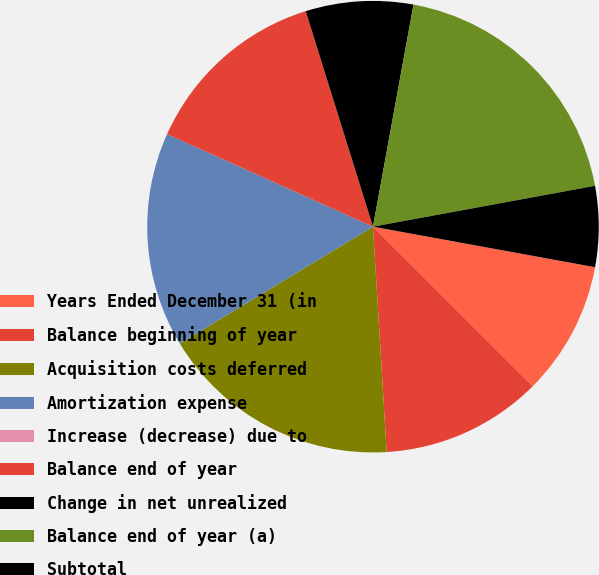<chart> <loc_0><loc_0><loc_500><loc_500><pie_chart><fcel>Years Ended December 31 (in<fcel>Balance beginning of year<fcel>Acquisition costs deferred<fcel>Amortization expense<fcel>Increase (decrease) due to<fcel>Balance end of year<fcel>Change in net unrealized<fcel>Balance end of year (a)<fcel>Subtotal<nl><fcel>9.62%<fcel>11.54%<fcel>17.31%<fcel>15.38%<fcel>0.0%<fcel>13.46%<fcel>7.69%<fcel>19.23%<fcel>5.77%<nl></chart> 